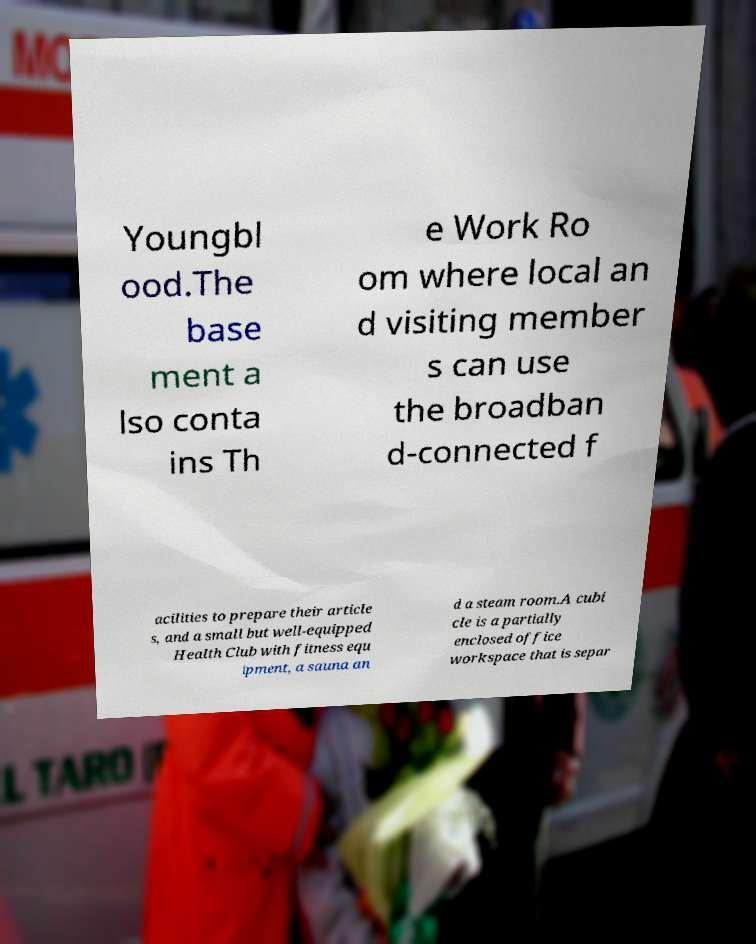Could you extract and type out the text from this image? Youngbl ood.The base ment a lso conta ins Th e Work Ro om where local an d visiting member s can use the broadban d-connected f acilities to prepare their article s, and a small but well-equipped Health Club with fitness equ ipment, a sauna an d a steam room.A cubi cle is a partially enclosed office workspace that is separ 